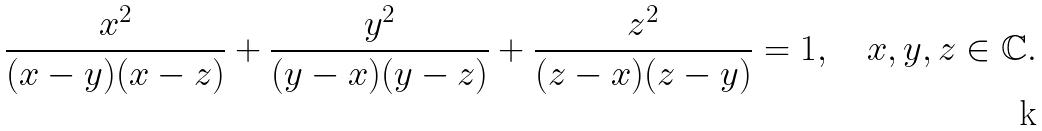<formula> <loc_0><loc_0><loc_500><loc_500>\frac { x ^ { 2 } } { ( x - y ) ( x - z ) } + \frac { y ^ { 2 } } { ( y - x ) ( y - z ) } + \frac { z ^ { 2 } } { ( z - x ) ( z - y ) } = 1 , \quad x , y , z \in \mathbb { C } .</formula> 